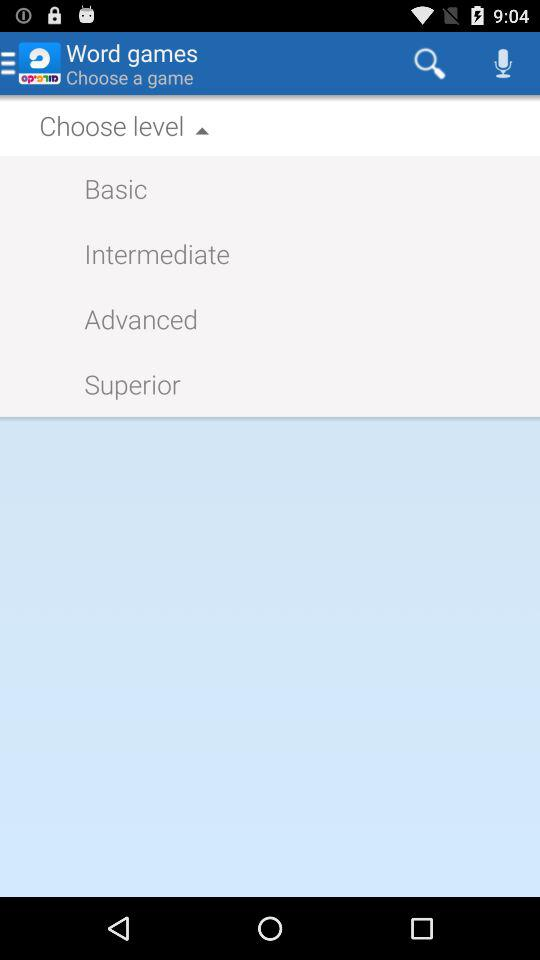How many levels are there in total?
Answer the question using a single word or phrase. 4 